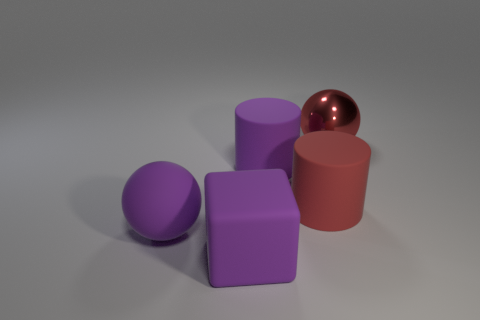Is there any other thing that is the same material as the red sphere?
Provide a succinct answer. No. Does the cylinder on the left side of the red matte object have the same size as the matte cube?
Keep it short and to the point. Yes. Are there any big objects that have the same color as the big rubber block?
Offer a terse response. Yes. There is a red rubber cylinder that is in front of the large metallic thing; are there any purple rubber objects that are on the left side of it?
Keep it short and to the point. Yes. Is there a big purple ball that has the same material as the big red cylinder?
Give a very brief answer. Yes. There is a ball in front of the large ball that is on the right side of the large purple rubber cylinder; what is it made of?
Your answer should be compact. Rubber. There is a thing that is both behind the red cylinder and right of the large purple cylinder; what material is it?
Offer a very short reply. Metal. Are there the same number of red matte objects that are to the left of the big purple matte ball and rubber balls?
Give a very brief answer. No. How many other large red shiny objects have the same shape as the metallic object?
Ensure brevity in your answer.  0. Do the large purple thing to the right of the purple matte block and the purple block have the same material?
Offer a terse response. Yes. 